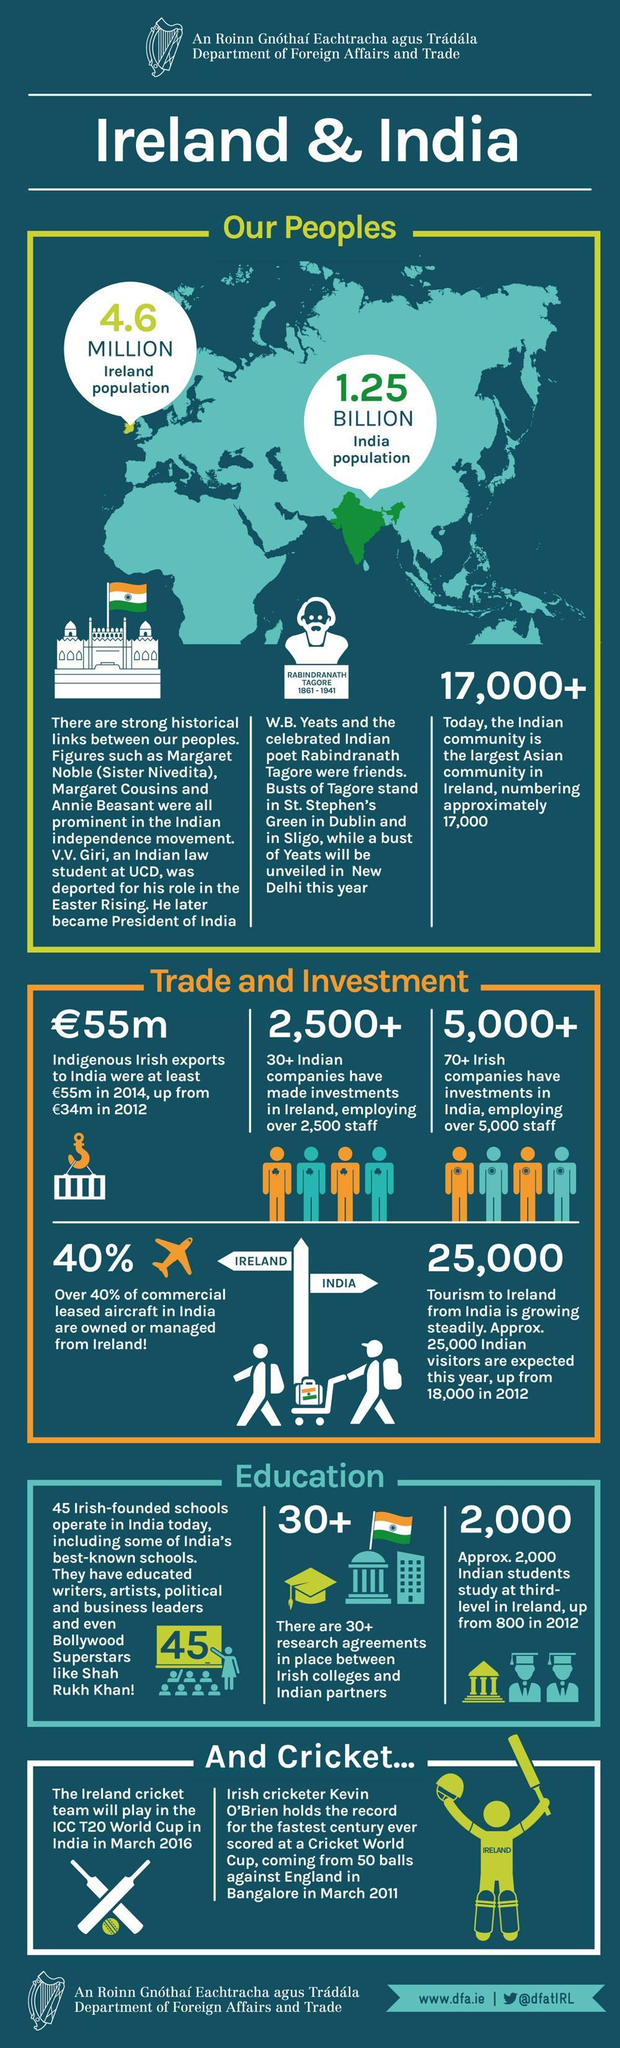Whose bust is shown in the image?
Answer the question with a short phrase. Rabindranath Tagore How many Indians study at 3rd level in Ireland (approx) ? 2000 How many images of the Indian flag are shown here? 2 Who was deported for his role in the Easter Rising? V. V. Giri What was the original name of sister Nivedita? Margaret Noble Who is the Irish poet whose bust will be unveiled in New Delhi ? W. B. Yeats What is written on the image of the cricketer? Ireland What is the population of India? 1.25 billion How much has indigenius Irish exports to India increased since 2012 (in million pounds)? 21 When compared to 2012, how many 'more' Indian tourists are expected this year? 7000 Whitch actor studied in an Irish founded school in India? Shah Rukh Khan What is the population of Ireland? 4.6 million Who holds the record for the fastest century ever scored? Kevin O'Brien How much staff is employed in the Irish companies in India (approx)? 5000 How many Indians are there in Ireland today (approx)? 17,000+ Which Indian poet was the friend of Yeats? Tagore What is the colour of India on the map - blue, yellow or green? Green How many research agreements are there between Irish colleges and Indian partners? 30+ 